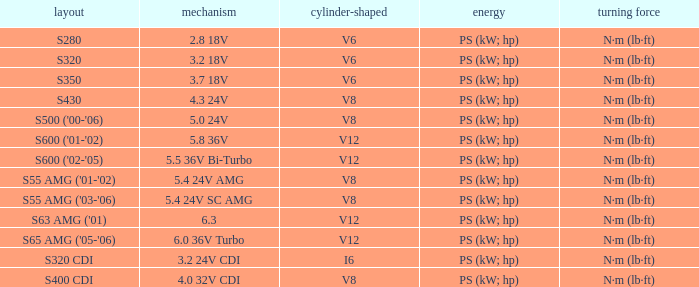Which Engine has a Model of s320 cdi? 3.2 24V CDI. 